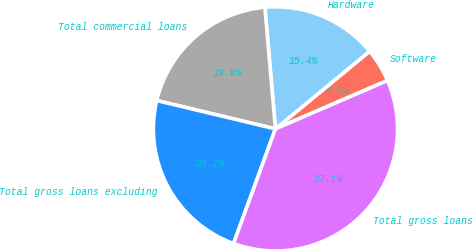Convert chart. <chart><loc_0><loc_0><loc_500><loc_500><pie_chart><fcel>Software<fcel>Hardware<fcel>Total commercial loans<fcel>Total gross loans excluding<fcel>Total gross loans<nl><fcel>4.49%<fcel>15.4%<fcel>19.89%<fcel>23.15%<fcel>37.06%<nl></chart> 